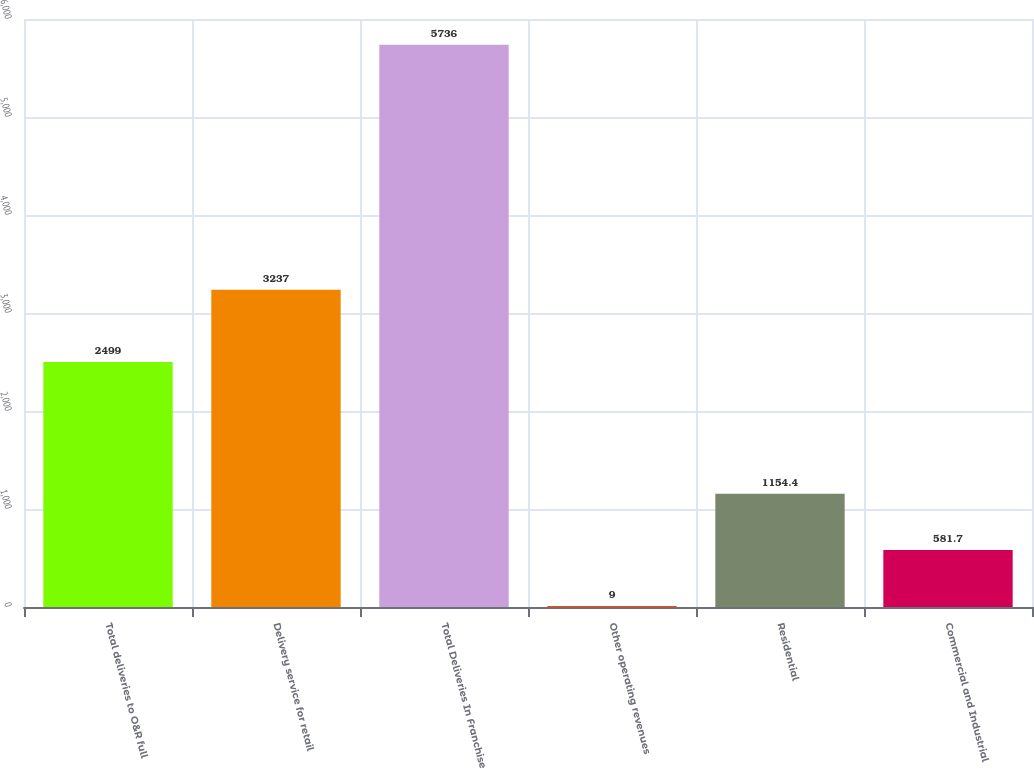Convert chart. <chart><loc_0><loc_0><loc_500><loc_500><bar_chart><fcel>Total deliveries to O&R full<fcel>Delivery service for retail<fcel>Total Deliveries In Franchise<fcel>Other operating revenues<fcel>Residential<fcel>Commercial and Industrial<nl><fcel>2499<fcel>3237<fcel>5736<fcel>9<fcel>1154.4<fcel>581.7<nl></chart> 